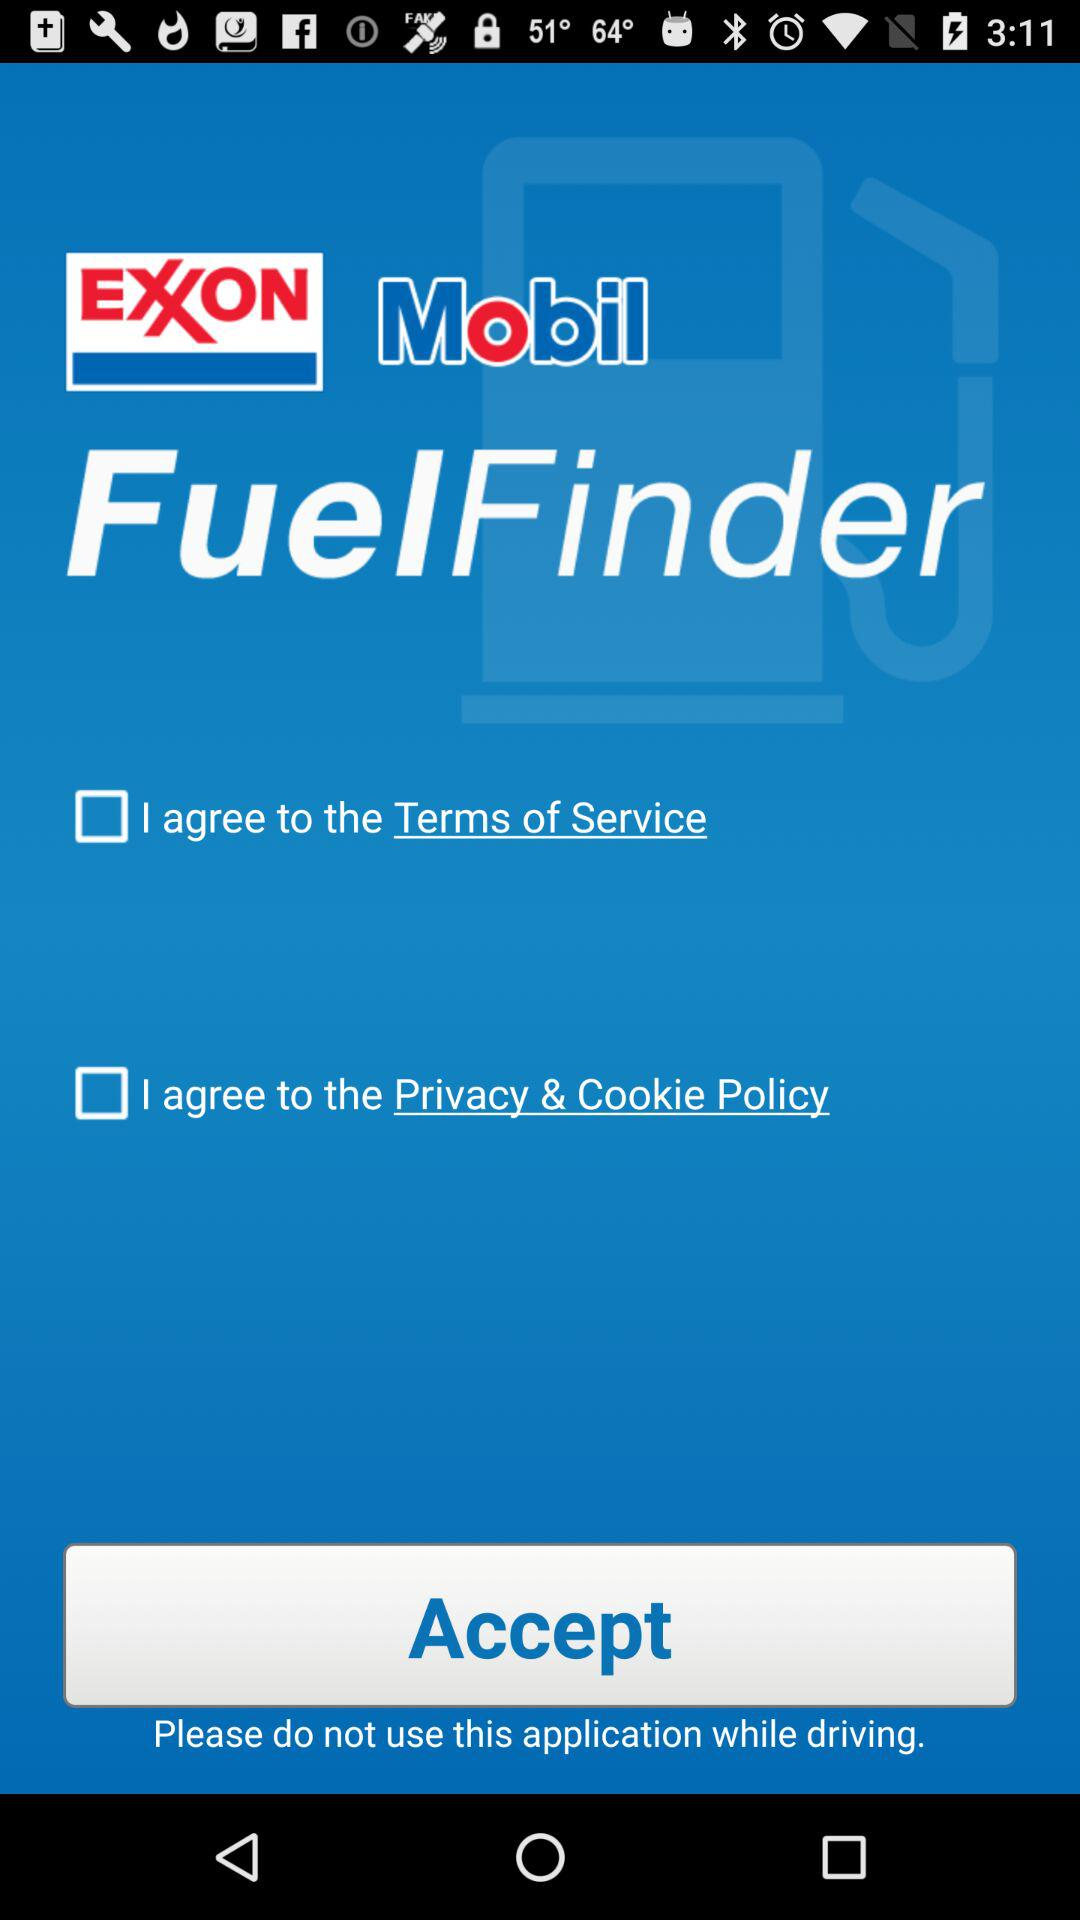What is the application name? The application name is "EXXON Mobil FuelFinder". 